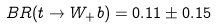<formula> <loc_0><loc_0><loc_500><loc_500>B R ( t \to W _ { + } b ) = 0 . 1 1 \pm 0 . 1 5</formula> 